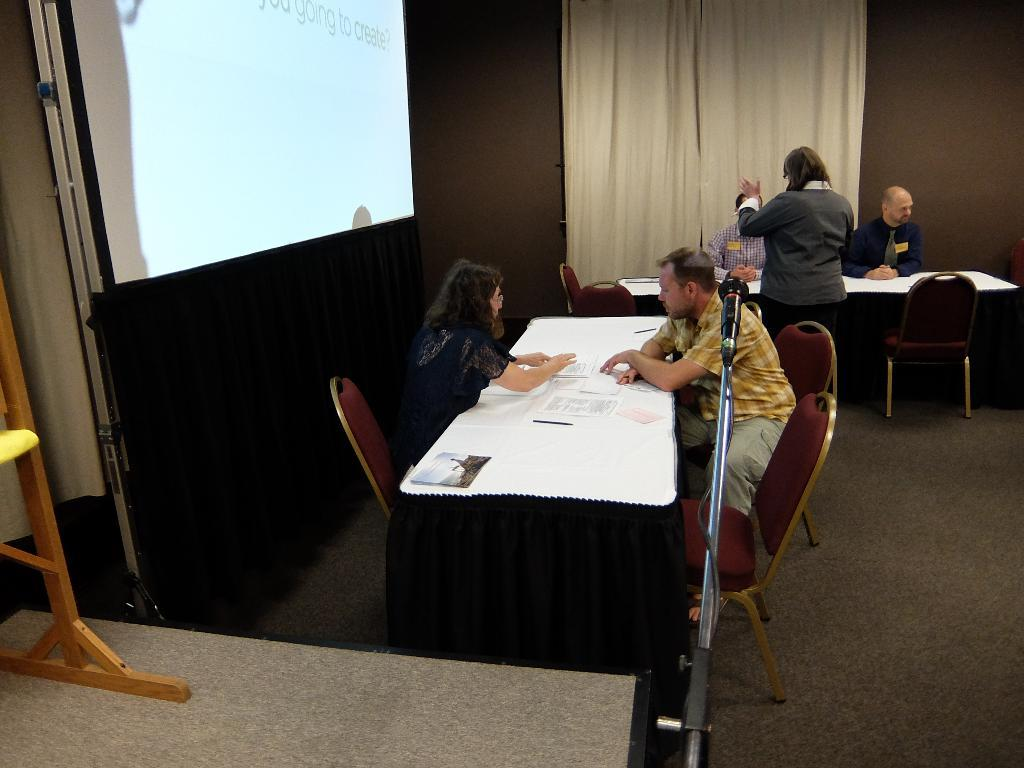What are the people in the image doing? The people in the image are seated on chairs. Can you describe the woman in the image? There is a woman standing in the image. What is on the table in the image? There are papers on a table in the image. What is on the left side of the image? There is a projector screen on the left side of the image. What type of stone is being used as a paperweight on the table in the image? There is no stone present on the table in the image; it only has papers. 